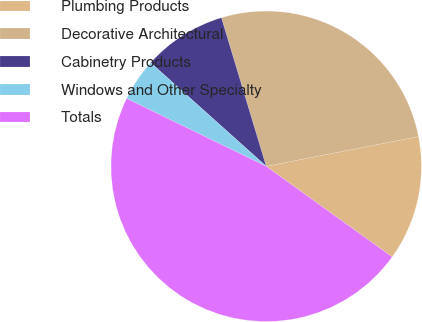Convert chart. <chart><loc_0><loc_0><loc_500><loc_500><pie_chart><fcel>Plumbing Products<fcel>Decorative Architectural<fcel>Cabinetry Products<fcel>Windows and Other Specialty<fcel>Totals<nl><fcel>13.0%<fcel>26.59%<fcel>8.71%<fcel>4.43%<fcel>47.27%<nl></chart> 